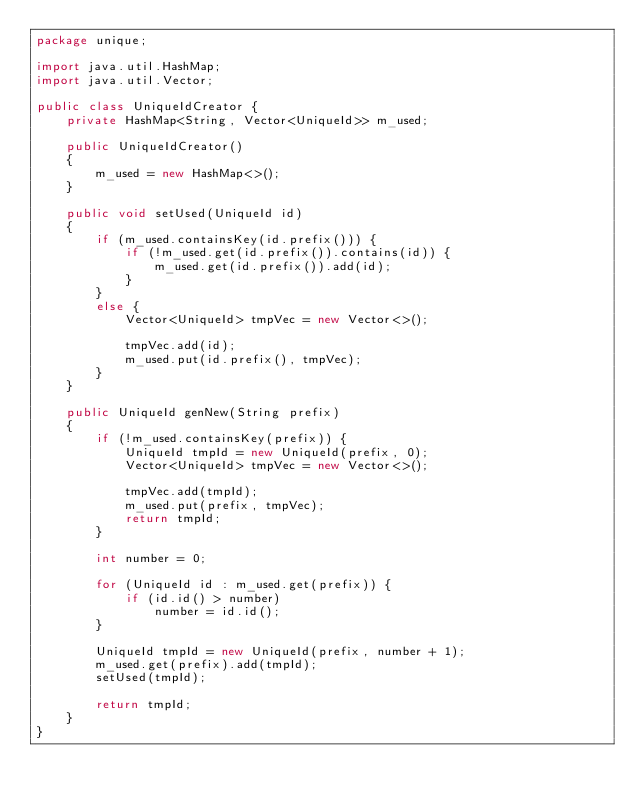Convert code to text. <code><loc_0><loc_0><loc_500><loc_500><_Java_>package unique;

import java.util.HashMap;
import java.util.Vector;

public class UniqueIdCreator {
    private HashMap<String, Vector<UniqueId>> m_used;

    public UniqueIdCreator()
    {
        m_used = new HashMap<>();
    }

    public void setUsed(UniqueId id)
    {
        if (m_used.containsKey(id.prefix())) {
            if (!m_used.get(id.prefix()).contains(id)) {
                m_used.get(id.prefix()).add(id);
            }
        }
        else {
            Vector<UniqueId> tmpVec = new Vector<>();

            tmpVec.add(id);
            m_used.put(id.prefix(), tmpVec);
        }
    }

    public UniqueId genNew(String prefix)
    {
        if (!m_used.containsKey(prefix)) {
            UniqueId tmpId = new UniqueId(prefix, 0);
            Vector<UniqueId> tmpVec = new Vector<>();

            tmpVec.add(tmpId);
            m_used.put(prefix, tmpVec);
            return tmpId;
        }

        int number = 0;

        for (UniqueId id : m_used.get(prefix)) {
            if (id.id() > number)
                number = id.id();
        }

        UniqueId tmpId = new UniqueId(prefix, number + 1);
        m_used.get(prefix).add(tmpId);
        setUsed(tmpId);

        return tmpId;
    }
}
</code> 